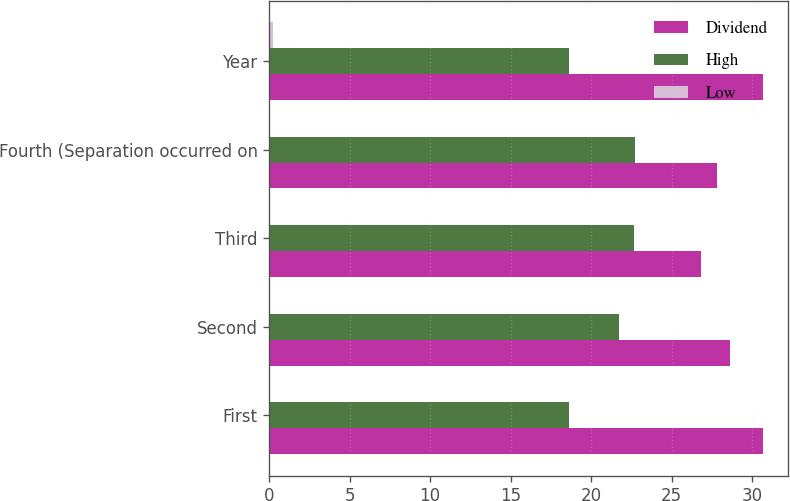<chart> <loc_0><loc_0><loc_500><loc_500><stacked_bar_chart><ecel><fcel>First<fcel>Second<fcel>Third<fcel>Fourth (Separation occurred on<fcel>Year<nl><fcel>Dividend<fcel>30.69<fcel>28.65<fcel>26.84<fcel>27.85<fcel>30.69<nl><fcel>High<fcel>18.64<fcel>21.76<fcel>22.67<fcel>22.74<fcel>18.64<nl><fcel>Low<fcel>0.06<fcel>0.06<fcel>0.06<fcel>0.06<fcel>0.24<nl></chart> 